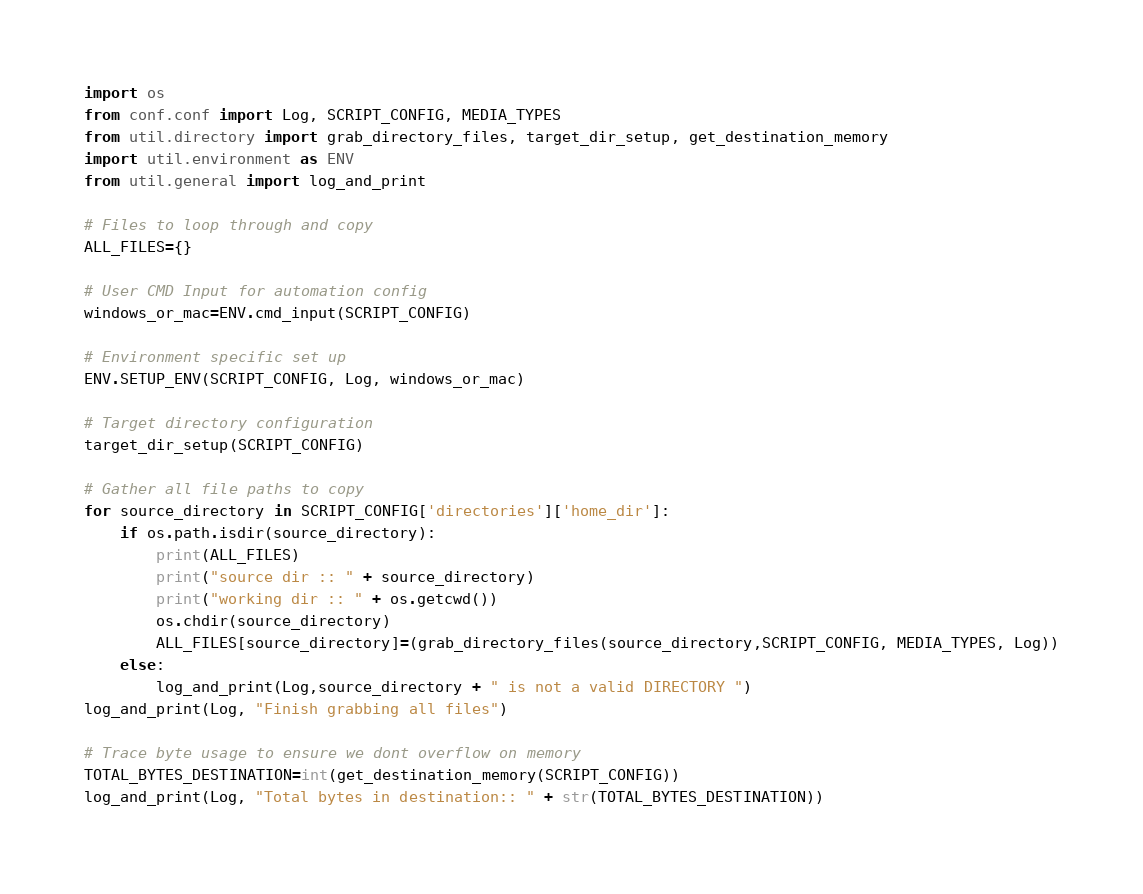Convert code to text. <code><loc_0><loc_0><loc_500><loc_500><_Python_>import os
from conf.conf import Log, SCRIPT_CONFIG, MEDIA_TYPES
from util.directory import grab_directory_files, target_dir_setup, get_destination_memory
import util.environment as ENV
from util.general import log_and_print

# Files to loop through and copy 
ALL_FILES={}

# User CMD Input for automation config
windows_or_mac=ENV.cmd_input(SCRIPT_CONFIG)

# Environment specific set up
ENV.SETUP_ENV(SCRIPT_CONFIG, Log, windows_or_mac)

# Target directory configuration 
target_dir_setup(SCRIPT_CONFIG)

# Gather all file paths to copy 
for source_directory in SCRIPT_CONFIG['directories']['home_dir']:
	if os.path.isdir(source_directory):
		print(ALL_FILES)
		print("source dir :: " + source_directory)
		print("working dir :: " + os.getcwd())
		os.chdir(source_directory)
		ALL_FILES[source_directory]=(grab_directory_files(source_directory,SCRIPT_CONFIG, MEDIA_TYPES, Log))
	else:
		log_and_print(Log,source_directory + " is not a valid DIRECTORY ")
log_and_print(Log, "Finish grabbing all files")

# Trace byte usage to ensure we dont overflow on memory
TOTAL_BYTES_DESTINATION=int(get_destination_memory(SCRIPT_CONFIG))
log_and_print(Log, "Total bytes in destination:: " + str(TOTAL_BYTES_DESTINATION))</code> 